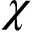Convert formula to latex. <formula><loc_0><loc_0><loc_500><loc_500>\chi</formula> 